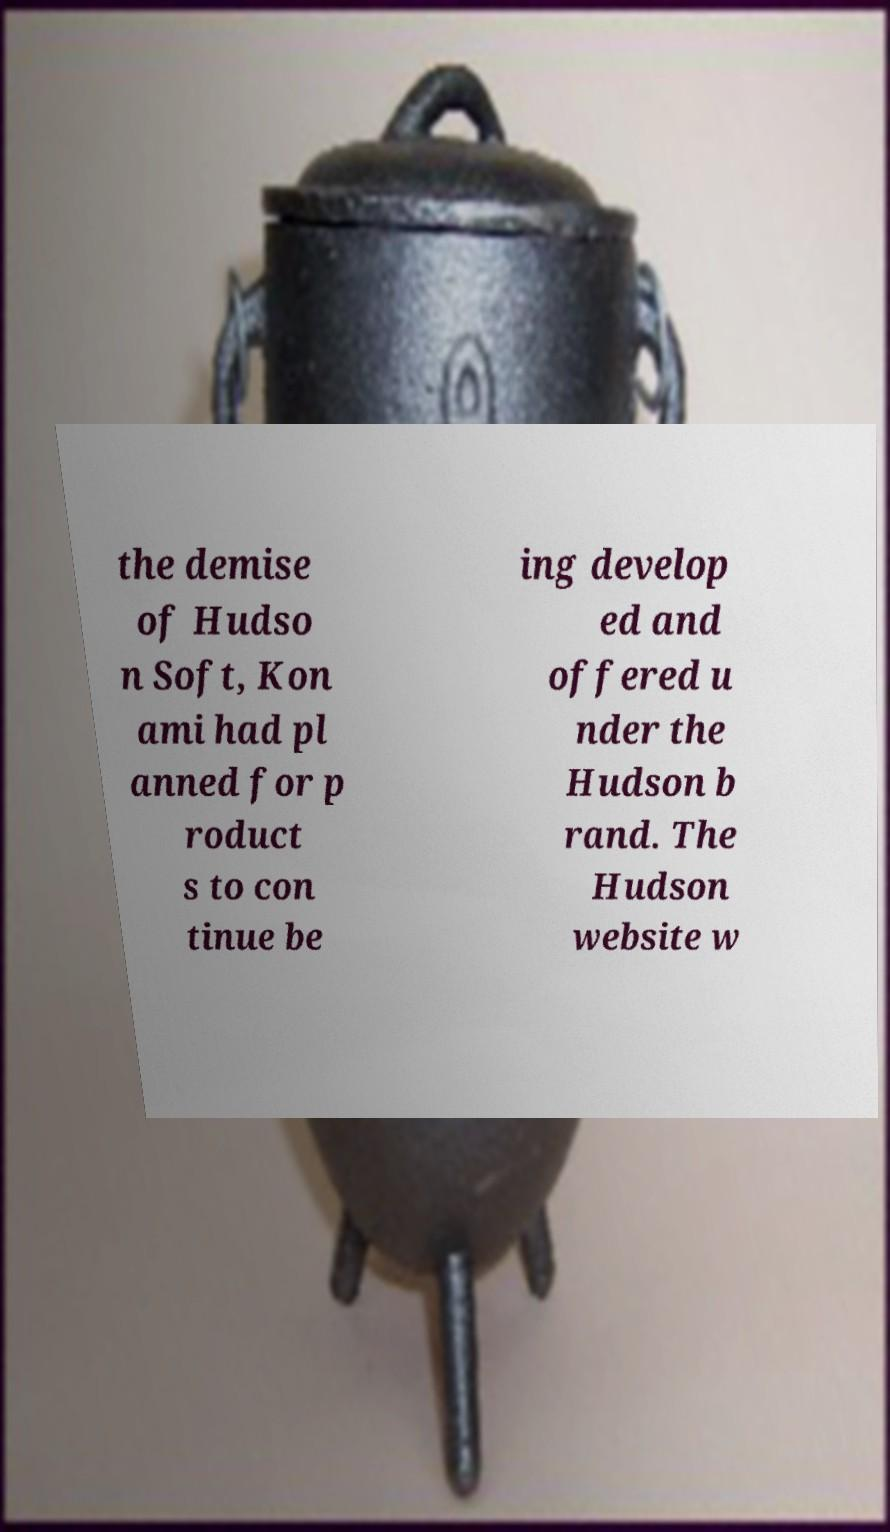Could you extract and type out the text from this image? the demise of Hudso n Soft, Kon ami had pl anned for p roduct s to con tinue be ing develop ed and offered u nder the Hudson b rand. The Hudson website w 